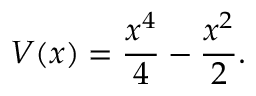<formula> <loc_0><loc_0><loc_500><loc_500>V ( x ) = \frac { x ^ { 4 } } { 4 } - \frac { x ^ { 2 } } { 2 } .</formula> 